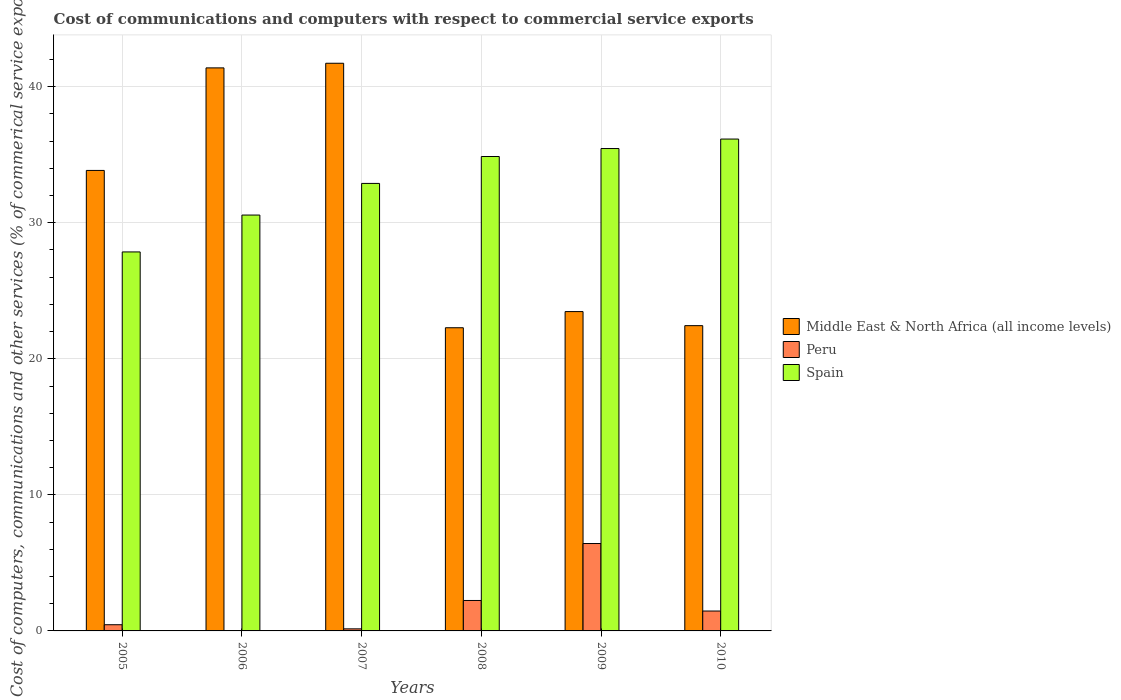How many different coloured bars are there?
Your answer should be very brief. 3. How many groups of bars are there?
Give a very brief answer. 6. Are the number of bars per tick equal to the number of legend labels?
Your answer should be very brief. No. What is the label of the 4th group of bars from the left?
Provide a short and direct response. 2008. In how many cases, is the number of bars for a given year not equal to the number of legend labels?
Ensure brevity in your answer.  1. What is the cost of communications and computers in Spain in 2008?
Give a very brief answer. 34.87. Across all years, what is the maximum cost of communications and computers in Spain?
Make the answer very short. 36.15. Across all years, what is the minimum cost of communications and computers in Spain?
Offer a very short reply. 27.85. What is the total cost of communications and computers in Spain in the graph?
Give a very brief answer. 197.78. What is the difference between the cost of communications and computers in Peru in 2007 and that in 2009?
Keep it short and to the point. -6.27. What is the difference between the cost of communications and computers in Spain in 2010 and the cost of communications and computers in Middle East & North Africa (all income levels) in 2005?
Make the answer very short. 2.31. What is the average cost of communications and computers in Peru per year?
Keep it short and to the point. 1.79. In the year 2006, what is the difference between the cost of communications and computers in Spain and cost of communications and computers in Middle East & North Africa (all income levels)?
Give a very brief answer. -10.82. In how many years, is the cost of communications and computers in Peru greater than 4 %?
Give a very brief answer. 1. What is the ratio of the cost of communications and computers in Peru in 2008 to that in 2010?
Your answer should be compact. 1.53. Is the cost of communications and computers in Spain in 2005 less than that in 2009?
Your answer should be compact. Yes. What is the difference between the highest and the second highest cost of communications and computers in Peru?
Your response must be concise. 4.19. What is the difference between the highest and the lowest cost of communications and computers in Spain?
Provide a succinct answer. 8.3. Is the sum of the cost of communications and computers in Middle East & North Africa (all income levels) in 2005 and 2010 greater than the maximum cost of communications and computers in Peru across all years?
Your answer should be compact. Yes. Is it the case that in every year, the sum of the cost of communications and computers in Spain and cost of communications and computers in Middle East & North Africa (all income levels) is greater than the cost of communications and computers in Peru?
Make the answer very short. Yes. Are all the bars in the graph horizontal?
Your answer should be compact. No. How many years are there in the graph?
Your response must be concise. 6. What is the difference between two consecutive major ticks on the Y-axis?
Provide a short and direct response. 10. Are the values on the major ticks of Y-axis written in scientific E-notation?
Keep it short and to the point. No. Does the graph contain any zero values?
Provide a succinct answer. Yes. Where does the legend appear in the graph?
Offer a terse response. Center right. What is the title of the graph?
Provide a short and direct response. Cost of communications and computers with respect to commercial service exports. What is the label or title of the X-axis?
Your answer should be very brief. Years. What is the label or title of the Y-axis?
Your answer should be compact. Cost of computers, communications and other services (% of commerical service exports). What is the Cost of computers, communications and other services (% of commerical service exports) in Middle East & North Africa (all income levels) in 2005?
Your answer should be very brief. 33.84. What is the Cost of computers, communications and other services (% of commerical service exports) of Peru in 2005?
Ensure brevity in your answer.  0.46. What is the Cost of computers, communications and other services (% of commerical service exports) in Spain in 2005?
Your answer should be compact. 27.85. What is the Cost of computers, communications and other services (% of commerical service exports) of Middle East & North Africa (all income levels) in 2006?
Your answer should be compact. 41.38. What is the Cost of computers, communications and other services (% of commerical service exports) in Spain in 2006?
Keep it short and to the point. 30.56. What is the Cost of computers, communications and other services (% of commerical service exports) of Middle East & North Africa (all income levels) in 2007?
Provide a succinct answer. 41.72. What is the Cost of computers, communications and other services (% of commerical service exports) of Peru in 2007?
Your answer should be compact. 0.15. What is the Cost of computers, communications and other services (% of commerical service exports) of Spain in 2007?
Keep it short and to the point. 32.89. What is the Cost of computers, communications and other services (% of commerical service exports) of Middle East & North Africa (all income levels) in 2008?
Your response must be concise. 22.28. What is the Cost of computers, communications and other services (% of commerical service exports) of Peru in 2008?
Give a very brief answer. 2.24. What is the Cost of computers, communications and other services (% of commerical service exports) of Spain in 2008?
Your answer should be compact. 34.87. What is the Cost of computers, communications and other services (% of commerical service exports) in Middle East & North Africa (all income levels) in 2009?
Your answer should be very brief. 23.47. What is the Cost of computers, communications and other services (% of commerical service exports) in Peru in 2009?
Your answer should be compact. 6.42. What is the Cost of computers, communications and other services (% of commerical service exports) in Spain in 2009?
Ensure brevity in your answer.  35.45. What is the Cost of computers, communications and other services (% of commerical service exports) in Middle East & North Africa (all income levels) in 2010?
Your answer should be compact. 22.44. What is the Cost of computers, communications and other services (% of commerical service exports) in Peru in 2010?
Your response must be concise. 1.46. What is the Cost of computers, communications and other services (% of commerical service exports) of Spain in 2010?
Provide a succinct answer. 36.15. Across all years, what is the maximum Cost of computers, communications and other services (% of commerical service exports) of Middle East & North Africa (all income levels)?
Offer a terse response. 41.72. Across all years, what is the maximum Cost of computers, communications and other services (% of commerical service exports) of Peru?
Your answer should be very brief. 6.42. Across all years, what is the maximum Cost of computers, communications and other services (% of commerical service exports) of Spain?
Keep it short and to the point. 36.15. Across all years, what is the minimum Cost of computers, communications and other services (% of commerical service exports) of Middle East & North Africa (all income levels)?
Offer a very short reply. 22.28. Across all years, what is the minimum Cost of computers, communications and other services (% of commerical service exports) in Peru?
Provide a succinct answer. 0. Across all years, what is the minimum Cost of computers, communications and other services (% of commerical service exports) in Spain?
Offer a terse response. 27.85. What is the total Cost of computers, communications and other services (% of commerical service exports) in Middle East & North Africa (all income levels) in the graph?
Provide a short and direct response. 185.13. What is the total Cost of computers, communications and other services (% of commerical service exports) in Peru in the graph?
Ensure brevity in your answer.  10.73. What is the total Cost of computers, communications and other services (% of commerical service exports) of Spain in the graph?
Ensure brevity in your answer.  197.78. What is the difference between the Cost of computers, communications and other services (% of commerical service exports) of Middle East & North Africa (all income levels) in 2005 and that in 2006?
Your answer should be very brief. -7.54. What is the difference between the Cost of computers, communications and other services (% of commerical service exports) of Spain in 2005 and that in 2006?
Provide a short and direct response. -2.71. What is the difference between the Cost of computers, communications and other services (% of commerical service exports) of Middle East & North Africa (all income levels) in 2005 and that in 2007?
Make the answer very short. -7.88. What is the difference between the Cost of computers, communications and other services (% of commerical service exports) in Peru in 2005 and that in 2007?
Give a very brief answer. 0.3. What is the difference between the Cost of computers, communications and other services (% of commerical service exports) in Spain in 2005 and that in 2007?
Offer a terse response. -5.04. What is the difference between the Cost of computers, communications and other services (% of commerical service exports) of Middle East & North Africa (all income levels) in 2005 and that in 2008?
Provide a succinct answer. 11.56. What is the difference between the Cost of computers, communications and other services (% of commerical service exports) of Peru in 2005 and that in 2008?
Your response must be concise. -1.78. What is the difference between the Cost of computers, communications and other services (% of commerical service exports) of Spain in 2005 and that in 2008?
Provide a succinct answer. -7.01. What is the difference between the Cost of computers, communications and other services (% of commerical service exports) of Middle East & North Africa (all income levels) in 2005 and that in 2009?
Your response must be concise. 10.37. What is the difference between the Cost of computers, communications and other services (% of commerical service exports) in Peru in 2005 and that in 2009?
Offer a very short reply. -5.97. What is the difference between the Cost of computers, communications and other services (% of commerical service exports) in Spain in 2005 and that in 2009?
Your answer should be compact. -7.6. What is the difference between the Cost of computers, communications and other services (% of commerical service exports) of Middle East & North Africa (all income levels) in 2005 and that in 2010?
Make the answer very short. 11.41. What is the difference between the Cost of computers, communications and other services (% of commerical service exports) of Peru in 2005 and that in 2010?
Provide a short and direct response. -1.01. What is the difference between the Cost of computers, communications and other services (% of commerical service exports) of Spain in 2005 and that in 2010?
Ensure brevity in your answer.  -8.3. What is the difference between the Cost of computers, communications and other services (% of commerical service exports) of Middle East & North Africa (all income levels) in 2006 and that in 2007?
Provide a short and direct response. -0.34. What is the difference between the Cost of computers, communications and other services (% of commerical service exports) of Spain in 2006 and that in 2007?
Your response must be concise. -2.33. What is the difference between the Cost of computers, communications and other services (% of commerical service exports) of Middle East & North Africa (all income levels) in 2006 and that in 2008?
Your answer should be very brief. 19.1. What is the difference between the Cost of computers, communications and other services (% of commerical service exports) in Spain in 2006 and that in 2008?
Provide a succinct answer. -4.3. What is the difference between the Cost of computers, communications and other services (% of commerical service exports) of Middle East & North Africa (all income levels) in 2006 and that in 2009?
Ensure brevity in your answer.  17.91. What is the difference between the Cost of computers, communications and other services (% of commerical service exports) of Spain in 2006 and that in 2009?
Your answer should be compact. -4.89. What is the difference between the Cost of computers, communications and other services (% of commerical service exports) in Middle East & North Africa (all income levels) in 2006 and that in 2010?
Your answer should be very brief. 18.94. What is the difference between the Cost of computers, communications and other services (% of commerical service exports) of Spain in 2006 and that in 2010?
Offer a very short reply. -5.59. What is the difference between the Cost of computers, communications and other services (% of commerical service exports) in Middle East & North Africa (all income levels) in 2007 and that in 2008?
Ensure brevity in your answer.  19.44. What is the difference between the Cost of computers, communications and other services (% of commerical service exports) in Peru in 2007 and that in 2008?
Provide a succinct answer. -2.09. What is the difference between the Cost of computers, communications and other services (% of commerical service exports) of Spain in 2007 and that in 2008?
Your answer should be very brief. -1.98. What is the difference between the Cost of computers, communications and other services (% of commerical service exports) in Middle East & North Africa (all income levels) in 2007 and that in 2009?
Offer a terse response. 18.25. What is the difference between the Cost of computers, communications and other services (% of commerical service exports) in Peru in 2007 and that in 2009?
Offer a terse response. -6.27. What is the difference between the Cost of computers, communications and other services (% of commerical service exports) of Spain in 2007 and that in 2009?
Ensure brevity in your answer.  -2.56. What is the difference between the Cost of computers, communications and other services (% of commerical service exports) in Middle East & North Africa (all income levels) in 2007 and that in 2010?
Give a very brief answer. 19.28. What is the difference between the Cost of computers, communications and other services (% of commerical service exports) in Peru in 2007 and that in 2010?
Your answer should be compact. -1.31. What is the difference between the Cost of computers, communications and other services (% of commerical service exports) of Spain in 2007 and that in 2010?
Make the answer very short. -3.26. What is the difference between the Cost of computers, communications and other services (% of commerical service exports) of Middle East & North Africa (all income levels) in 2008 and that in 2009?
Ensure brevity in your answer.  -1.19. What is the difference between the Cost of computers, communications and other services (% of commerical service exports) of Peru in 2008 and that in 2009?
Provide a short and direct response. -4.19. What is the difference between the Cost of computers, communications and other services (% of commerical service exports) in Spain in 2008 and that in 2009?
Give a very brief answer. -0.59. What is the difference between the Cost of computers, communications and other services (% of commerical service exports) in Middle East & North Africa (all income levels) in 2008 and that in 2010?
Give a very brief answer. -0.15. What is the difference between the Cost of computers, communications and other services (% of commerical service exports) of Peru in 2008 and that in 2010?
Your answer should be very brief. 0.78. What is the difference between the Cost of computers, communications and other services (% of commerical service exports) of Spain in 2008 and that in 2010?
Ensure brevity in your answer.  -1.28. What is the difference between the Cost of computers, communications and other services (% of commerical service exports) in Peru in 2009 and that in 2010?
Your response must be concise. 4.96. What is the difference between the Cost of computers, communications and other services (% of commerical service exports) of Spain in 2009 and that in 2010?
Offer a very short reply. -0.7. What is the difference between the Cost of computers, communications and other services (% of commerical service exports) in Middle East & North Africa (all income levels) in 2005 and the Cost of computers, communications and other services (% of commerical service exports) in Spain in 2006?
Ensure brevity in your answer.  3.28. What is the difference between the Cost of computers, communications and other services (% of commerical service exports) in Peru in 2005 and the Cost of computers, communications and other services (% of commerical service exports) in Spain in 2006?
Make the answer very short. -30.11. What is the difference between the Cost of computers, communications and other services (% of commerical service exports) of Middle East & North Africa (all income levels) in 2005 and the Cost of computers, communications and other services (% of commerical service exports) of Peru in 2007?
Offer a terse response. 33.69. What is the difference between the Cost of computers, communications and other services (% of commerical service exports) in Middle East & North Africa (all income levels) in 2005 and the Cost of computers, communications and other services (% of commerical service exports) in Spain in 2007?
Give a very brief answer. 0.95. What is the difference between the Cost of computers, communications and other services (% of commerical service exports) in Peru in 2005 and the Cost of computers, communications and other services (% of commerical service exports) in Spain in 2007?
Make the answer very short. -32.43. What is the difference between the Cost of computers, communications and other services (% of commerical service exports) in Middle East & North Africa (all income levels) in 2005 and the Cost of computers, communications and other services (% of commerical service exports) in Peru in 2008?
Offer a very short reply. 31.61. What is the difference between the Cost of computers, communications and other services (% of commerical service exports) in Middle East & North Africa (all income levels) in 2005 and the Cost of computers, communications and other services (% of commerical service exports) in Spain in 2008?
Provide a succinct answer. -1.02. What is the difference between the Cost of computers, communications and other services (% of commerical service exports) in Peru in 2005 and the Cost of computers, communications and other services (% of commerical service exports) in Spain in 2008?
Keep it short and to the point. -34.41. What is the difference between the Cost of computers, communications and other services (% of commerical service exports) of Middle East & North Africa (all income levels) in 2005 and the Cost of computers, communications and other services (% of commerical service exports) of Peru in 2009?
Offer a terse response. 27.42. What is the difference between the Cost of computers, communications and other services (% of commerical service exports) of Middle East & North Africa (all income levels) in 2005 and the Cost of computers, communications and other services (% of commerical service exports) of Spain in 2009?
Your answer should be compact. -1.61. What is the difference between the Cost of computers, communications and other services (% of commerical service exports) of Peru in 2005 and the Cost of computers, communications and other services (% of commerical service exports) of Spain in 2009?
Make the answer very short. -35. What is the difference between the Cost of computers, communications and other services (% of commerical service exports) in Middle East & North Africa (all income levels) in 2005 and the Cost of computers, communications and other services (% of commerical service exports) in Peru in 2010?
Offer a very short reply. 32.38. What is the difference between the Cost of computers, communications and other services (% of commerical service exports) in Middle East & North Africa (all income levels) in 2005 and the Cost of computers, communications and other services (% of commerical service exports) in Spain in 2010?
Your answer should be very brief. -2.31. What is the difference between the Cost of computers, communications and other services (% of commerical service exports) in Peru in 2005 and the Cost of computers, communications and other services (% of commerical service exports) in Spain in 2010?
Provide a short and direct response. -35.69. What is the difference between the Cost of computers, communications and other services (% of commerical service exports) in Middle East & North Africa (all income levels) in 2006 and the Cost of computers, communications and other services (% of commerical service exports) in Peru in 2007?
Keep it short and to the point. 41.23. What is the difference between the Cost of computers, communications and other services (% of commerical service exports) in Middle East & North Africa (all income levels) in 2006 and the Cost of computers, communications and other services (% of commerical service exports) in Spain in 2007?
Ensure brevity in your answer.  8.49. What is the difference between the Cost of computers, communications and other services (% of commerical service exports) in Middle East & North Africa (all income levels) in 2006 and the Cost of computers, communications and other services (% of commerical service exports) in Peru in 2008?
Your response must be concise. 39.14. What is the difference between the Cost of computers, communications and other services (% of commerical service exports) of Middle East & North Africa (all income levels) in 2006 and the Cost of computers, communications and other services (% of commerical service exports) of Spain in 2008?
Keep it short and to the point. 6.51. What is the difference between the Cost of computers, communications and other services (% of commerical service exports) in Middle East & North Africa (all income levels) in 2006 and the Cost of computers, communications and other services (% of commerical service exports) in Peru in 2009?
Keep it short and to the point. 34.96. What is the difference between the Cost of computers, communications and other services (% of commerical service exports) in Middle East & North Africa (all income levels) in 2006 and the Cost of computers, communications and other services (% of commerical service exports) in Spain in 2009?
Make the answer very short. 5.93. What is the difference between the Cost of computers, communications and other services (% of commerical service exports) in Middle East & North Africa (all income levels) in 2006 and the Cost of computers, communications and other services (% of commerical service exports) in Peru in 2010?
Make the answer very short. 39.92. What is the difference between the Cost of computers, communications and other services (% of commerical service exports) in Middle East & North Africa (all income levels) in 2006 and the Cost of computers, communications and other services (% of commerical service exports) in Spain in 2010?
Ensure brevity in your answer.  5.23. What is the difference between the Cost of computers, communications and other services (% of commerical service exports) in Middle East & North Africa (all income levels) in 2007 and the Cost of computers, communications and other services (% of commerical service exports) in Peru in 2008?
Ensure brevity in your answer.  39.48. What is the difference between the Cost of computers, communications and other services (% of commerical service exports) of Middle East & North Africa (all income levels) in 2007 and the Cost of computers, communications and other services (% of commerical service exports) of Spain in 2008?
Ensure brevity in your answer.  6.85. What is the difference between the Cost of computers, communications and other services (% of commerical service exports) in Peru in 2007 and the Cost of computers, communications and other services (% of commerical service exports) in Spain in 2008?
Your response must be concise. -34.71. What is the difference between the Cost of computers, communications and other services (% of commerical service exports) in Middle East & North Africa (all income levels) in 2007 and the Cost of computers, communications and other services (% of commerical service exports) in Peru in 2009?
Your answer should be compact. 35.3. What is the difference between the Cost of computers, communications and other services (% of commerical service exports) in Middle East & North Africa (all income levels) in 2007 and the Cost of computers, communications and other services (% of commerical service exports) in Spain in 2009?
Make the answer very short. 6.27. What is the difference between the Cost of computers, communications and other services (% of commerical service exports) in Peru in 2007 and the Cost of computers, communications and other services (% of commerical service exports) in Spain in 2009?
Keep it short and to the point. -35.3. What is the difference between the Cost of computers, communications and other services (% of commerical service exports) of Middle East & North Africa (all income levels) in 2007 and the Cost of computers, communications and other services (% of commerical service exports) of Peru in 2010?
Your answer should be compact. 40.26. What is the difference between the Cost of computers, communications and other services (% of commerical service exports) in Middle East & North Africa (all income levels) in 2007 and the Cost of computers, communications and other services (% of commerical service exports) in Spain in 2010?
Offer a very short reply. 5.57. What is the difference between the Cost of computers, communications and other services (% of commerical service exports) in Peru in 2007 and the Cost of computers, communications and other services (% of commerical service exports) in Spain in 2010?
Provide a short and direct response. -36. What is the difference between the Cost of computers, communications and other services (% of commerical service exports) of Middle East & North Africa (all income levels) in 2008 and the Cost of computers, communications and other services (% of commerical service exports) of Peru in 2009?
Ensure brevity in your answer.  15.86. What is the difference between the Cost of computers, communications and other services (% of commerical service exports) of Middle East & North Africa (all income levels) in 2008 and the Cost of computers, communications and other services (% of commerical service exports) of Spain in 2009?
Your answer should be very brief. -13.17. What is the difference between the Cost of computers, communications and other services (% of commerical service exports) of Peru in 2008 and the Cost of computers, communications and other services (% of commerical service exports) of Spain in 2009?
Your response must be concise. -33.22. What is the difference between the Cost of computers, communications and other services (% of commerical service exports) in Middle East & North Africa (all income levels) in 2008 and the Cost of computers, communications and other services (% of commerical service exports) in Peru in 2010?
Ensure brevity in your answer.  20.82. What is the difference between the Cost of computers, communications and other services (% of commerical service exports) of Middle East & North Africa (all income levels) in 2008 and the Cost of computers, communications and other services (% of commerical service exports) of Spain in 2010?
Offer a very short reply. -13.87. What is the difference between the Cost of computers, communications and other services (% of commerical service exports) in Peru in 2008 and the Cost of computers, communications and other services (% of commerical service exports) in Spain in 2010?
Keep it short and to the point. -33.91. What is the difference between the Cost of computers, communications and other services (% of commerical service exports) in Middle East & North Africa (all income levels) in 2009 and the Cost of computers, communications and other services (% of commerical service exports) in Peru in 2010?
Offer a terse response. 22.01. What is the difference between the Cost of computers, communications and other services (% of commerical service exports) in Middle East & North Africa (all income levels) in 2009 and the Cost of computers, communications and other services (% of commerical service exports) in Spain in 2010?
Keep it short and to the point. -12.68. What is the difference between the Cost of computers, communications and other services (% of commerical service exports) of Peru in 2009 and the Cost of computers, communications and other services (% of commerical service exports) of Spain in 2010?
Your response must be concise. -29.73. What is the average Cost of computers, communications and other services (% of commerical service exports) of Middle East & North Africa (all income levels) per year?
Provide a succinct answer. 30.86. What is the average Cost of computers, communications and other services (% of commerical service exports) of Peru per year?
Keep it short and to the point. 1.79. What is the average Cost of computers, communications and other services (% of commerical service exports) in Spain per year?
Give a very brief answer. 32.96. In the year 2005, what is the difference between the Cost of computers, communications and other services (% of commerical service exports) in Middle East & North Africa (all income levels) and Cost of computers, communications and other services (% of commerical service exports) in Peru?
Your answer should be very brief. 33.39. In the year 2005, what is the difference between the Cost of computers, communications and other services (% of commerical service exports) in Middle East & North Africa (all income levels) and Cost of computers, communications and other services (% of commerical service exports) in Spain?
Your answer should be compact. 5.99. In the year 2005, what is the difference between the Cost of computers, communications and other services (% of commerical service exports) of Peru and Cost of computers, communications and other services (% of commerical service exports) of Spain?
Provide a short and direct response. -27.4. In the year 2006, what is the difference between the Cost of computers, communications and other services (% of commerical service exports) of Middle East & North Africa (all income levels) and Cost of computers, communications and other services (% of commerical service exports) of Spain?
Your response must be concise. 10.82. In the year 2007, what is the difference between the Cost of computers, communications and other services (% of commerical service exports) of Middle East & North Africa (all income levels) and Cost of computers, communications and other services (% of commerical service exports) of Peru?
Keep it short and to the point. 41.57. In the year 2007, what is the difference between the Cost of computers, communications and other services (% of commerical service exports) of Middle East & North Africa (all income levels) and Cost of computers, communications and other services (% of commerical service exports) of Spain?
Ensure brevity in your answer.  8.83. In the year 2007, what is the difference between the Cost of computers, communications and other services (% of commerical service exports) in Peru and Cost of computers, communications and other services (% of commerical service exports) in Spain?
Provide a succinct answer. -32.74. In the year 2008, what is the difference between the Cost of computers, communications and other services (% of commerical service exports) of Middle East & North Africa (all income levels) and Cost of computers, communications and other services (% of commerical service exports) of Peru?
Keep it short and to the point. 20.05. In the year 2008, what is the difference between the Cost of computers, communications and other services (% of commerical service exports) in Middle East & North Africa (all income levels) and Cost of computers, communications and other services (% of commerical service exports) in Spain?
Provide a short and direct response. -12.58. In the year 2008, what is the difference between the Cost of computers, communications and other services (% of commerical service exports) in Peru and Cost of computers, communications and other services (% of commerical service exports) in Spain?
Give a very brief answer. -32.63. In the year 2009, what is the difference between the Cost of computers, communications and other services (% of commerical service exports) in Middle East & North Africa (all income levels) and Cost of computers, communications and other services (% of commerical service exports) in Peru?
Give a very brief answer. 17.05. In the year 2009, what is the difference between the Cost of computers, communications and other services (% of commerical service exports) of Middle East & North Africa (all income levels) and Cost of computers, communications and other services (% of commerical service exports) of Spain?
Keep it short and to the point. -11.98. In the year 2009, what is the difference between the Cost of computers, communications and other services (% of commerical service exports) of Peru and Cost of computers, communications and other services (% of commerical service exports) of Spain?
Provide a short and direct response. -29.03. In the year 2010, what is the difference between the Cost of computers, communications and other services (% of commerical service exports) in Middle East & North Africa (all income levels) and Cost of computers, communications and other services (% of commerical service exports) in Peru?
Your answer should be very brief. 20.97. In the year 2010, what is the difference between the Cost of computers, communications and other services (% of commerical service exports) of Middle East & North Africa (all income levels) and Cost of computers, communications and other services (% of commerical service exports) of Spain?
Offer a very short reply. -13.71. In the year 2010, what is the difference between the Cost of computers, communications and other services (% of commerical service exports) of Peru and Cost of computers, communications and other services (% of commerical service exports) of Spain?
Your answer should be compact. -34.69. What is the ratio of the Cost of computers, communications and other services (% of commerical service exports) in Middle East & North Africa (all income levels) in 2005 to that in 2006?
Your response must be concise. 0.82. What is the ratio of the Cost of computers, communications and other services (% of commerical service exports) in Spain in 2005 to that in 2006?
Your answer should be compact. 0.91. What is the ratio of the Cost of computers, communications and other services (% of commerical service exports) in Middle East & North Africa (all income levels) in 2005 to that in 2007?
Your answer should be compact. 0.81. What is the ratio of the Cost of computers, communications and other services (% of commerical service exports) in Peru in 2005 to that in 2007?
Your answer should be compact. 2.99. What is the ratio of the Cost of computers, communications and other services (% of commerical service exports) of Spain in 2005 to that in 2007?
Your answer should be compact. 0.85. What is the ratio of the Cost of computers, communications and other services (% of commerical service exports) of Middle East & North Africa (all income levels) in 2005 to that in 2008?
Your response must be concise. 1.52. What is the ratio of the Cost of computers, communications and other services (% of commerical service exports) of Peru in 2005 to that in 2008?
Keep it short and to the point. 0.2. What is the ratio of the Cost of computers, communications and other services (% of commerical service exports) of Spain in 2005 to that in 2008?
Make the answer very short. 0.8. What is the ratio of the Cost of computers, communications and other services (% of commerical service exports) in Middle East & North Africa (all income levels) in 2005 to that in 2009?
Offer a very short reply. 1.44. What is the ratio of the Cost of computers, communications and other services (% of commerical service exports) in Peru in 2005 to that in 2009?
Give a very brief answer. 0.07. What is the ratio of the Cost of computers, communications and other services (% of commerical service exports) of Spain in 2005 to that in 2009?
Your answer should be compact. 0.79. What is the ratio of the Cost of computers, communications and other services (% of commerical service exports) in Middle East & North Africa (all income levels) in 2005 to that in 2010?
Your answer should be compact. 1.51. What is the ratio of the Cost of computers, communications and other services (% of commerical service exports) of Peru in 2005 to that in 2010?
Give a very brief answer. 0.31. What is the ratio of the Cost of computers, communications and other services (% of commerical service exports) of Spain in 2005 to that in 2010?
Offer a terse response. 0.77. What is the ratio of the Cost of computers, communications and other services (% of commerical service exports) of Spain in 2006 to that in 2007?
Offer a very short reply. 0.93. What is the ratio of the Cost of computers, communications and other services (% of commerical service exports) of Middle East & North Africa (all income levels) in 2006 to that in 2008?
Keep it short and to the point. 1.86. What is the ratio of the Cost of computers, communications and other services (% of commerical service exports) of Spain in 2006 to that in 2008?
Ensure brevity in your answer.  0.88. What is the ratio of the Cost of computers, communications and other services (% of commerical service exports) of Middle East & North Africa (all income levels) in 2006 to that in 2009?
Your response must be concise. 1.76. What is the ratio of the Cost of computers, communications and other services (% of commerical service exports) of Spain in 2006 to that in 2009?
Provide a short and direct response. 0.86. What is the ratio of the Cost of computers, communications and other services (% of commerical service exports) in Middle East & North Africa (all income levels) in 2006 to that in 2010?
Your answer should be very brief. 1.84. What is the ratio of the Cost of computers, communications and other services (% of commerical service exports) of Spain in 2006 to that in 2010?
Provide a short and direct response. 0.85. What is the ratio of the Cost of computers, communications and other services (% of commerical service exports) of Middle East & North Africa (all income levels) in 2007 to that in 2008?
Provide a short and direct response. 1.87. What is the ratio of the Cost of computers, communications and other services (% of commerical service exports) of Peru in 2007 to that in 2008?
Give a very brief answer. 0.07. What is the ratio of the Cost of computers, communications and other services (% of commerical service exports) of Spain in 2007 to that in 2008?
Offer a terse response. 0.94. What is the ratio of the Cost of computers, communications and other services (% of commerical service exports) of Middle East & North Africa (all income levels) in 2007 to that in 2009?
Provide a short and direct response. 1.78. What is the ratio of the Cost of computers, communications and other services (% of commerical service exports) of Peru in 2007 to that in 2009?
Offer a very short reply. 0.02. What is the ratio of the Cost of computers, communications and other services (% of commerical service exports) in Spain in 2007 to that in 2009?
Give a very brief answer. 0.93. What is the ratio of the Cost of computers, communications and other services (% of commerical service exports) in Middle East & North Africa (all income levels) in 2007 to that in 2010?
Keep it short and to the point. 1.86. What is the ratio of the Cost of computers, communications and other services (% of commerical service exports) in Peru in 2007 to that in 2010?
Make the answer very short. 0.1. What is the ratio of the Cost of computers, communications and other services (% of commerical service exports) of Spain in 2007 to that in 2010?
Offer a terse response. 0.91. What is the ratio of the Cost of computers, communications and other services (% of commerical service exports) in Middle East & North Africa (all income levels) in 2008 to that in 2009?
Offer a terse response. 0.95. What is the ratio of the Cost of computers, communications and other services (% of commerical service exports) in Peru in 2008 to that in 2009?
Provide a succinct answer. 0.35. What is the ratio of the Cost of computers, communications and other services (% of commerical service exports) of Spain in 2008 to that in 2009?
Give a very brief answer. 0.98. What is the ratio of the Cost of computers, communications and other services (% of commerical service exports) of Middle East & North Africa (all income levels) in 2008 to that in 2010?
Keep it short and to the point. 0.99. What is the ratio of the Cost of computers, communications and other services (% of commerical service exports) of Peru in 2008 to that in 2010?
Your answer should be compact. 1.53. What is the ratio of the Cost of computers, communications and other services (% of commerical service exports) in Spain in 2008 to that in 2010?
Offer a terse response. 0.96. What is the ratio of the Cost of computers, communications and other services (% of commerical service exports) in Middle East & North Africa (all income levels) in 2009 to that in 2010?
Your answer should be compact. 1.05. What is the ratio of the Cost of computers, communications and other services (% of commerical service exports) in Peru in 2009 to that in 2010?
Ensure brevity in your answer.  4.39. What is the ratio of the Cost of computers, communications and other services (% of commerical service exports) of Spain in 2009 to that in 2010?
Keep it short and to the point. 0.98. What is the difference between the highest and the second highest Cost of computers, communications and other services (% of commerical service exports) in Middle East & North Africa (all income levels)?
Your response must be concise. 0.34. What is the difference between the highest and the second highest Cost of computers, communications and other services (% of commerical service exports) in Peru?
Keep it short and to the point. 4.19. What is the difference between the highest and the second highest Cost of computers, communications and other services (% of commerical service exports) in Spain?
Ensure brevity in your answer.  0.7. What is the difference between the highest and the lowest Cost of computers, communications and other services (% of commerical service exports) of Middle East & North Africa (all income levels)?
Your answer should be very brief. 19.44. What is the difference between the highest and the lowest Cost of computers, communications and other services (% of commerical service exports) in Peru?
Ensure brevity in your answer.  6.42. What is the difference between the highest and the lowest Cost of computers, communications and other services (% of commerical service exports) in Spain?
Your answer should be compact. 8.3. 